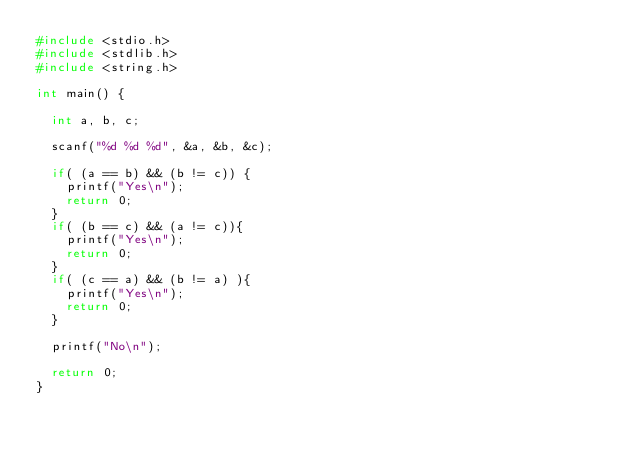<code> <loc_0><loc_0><loc_500><loc_500><_C_>#include <stdio.h>
#include <stdlib.h>
#include <string.h>

int main() {

	int a, b, c;

	scanf("%d %d %d", &a, &b, &c);

	if( (a == b) && (b != c)) {
		printf("Yes\n");
		return 0;
	}
	if( (b == c) && (a != c)){
		printf("Yes\n");
		return 0;
	}
	if( (c == a) && (b != a) ){
		printf("Yes\n");
		return 0;
	}

	printf("No\n");

	return 0;
}
</code> 